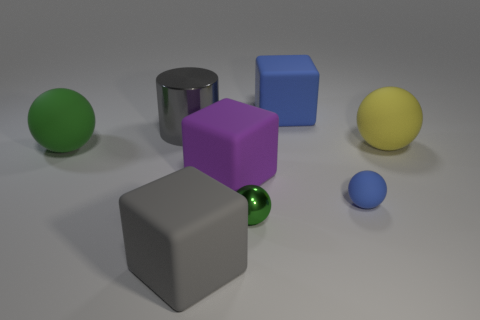There is a tiny blue matte object; does it have the same shape as the gray object in front of the big green matte object?
Ensure brevity in your answer.  No. The big gray thing that is in front of the matte ball that is on the right side of the small matte sphere is made of what material?
Your answer should be compact. Rubber. Are there an equal number of yellow things that are on the left side of the blue cube and small purple spheres?
Keep it short and to the point. Yes. Do the rubber sphere in front of the big green thing and the big rubber thing that is behind the large shiny object have the same color?
Your answer should be compact. Yes. What number of objects are both in front of the gray cylinder and right of the big green ball?
Your answer should be very brief. 5. How many other objects are there of the same shape as the purple thing?
Keep it short and to the point. 2. Is the number of blue objects behind the purple rubber object greater than the number of small yellow cylinders?
Your response must be concise. Yes. What color is the rubber block on the right side of the tiny green sphere?
Make the answer very short. Blue. The matte thing that is the same color as the cylinder is what size?
Your answer should be very brief. Large. What number of shiny objects are big spheres or purple cubes?
Provide a short and direct response. 0. 